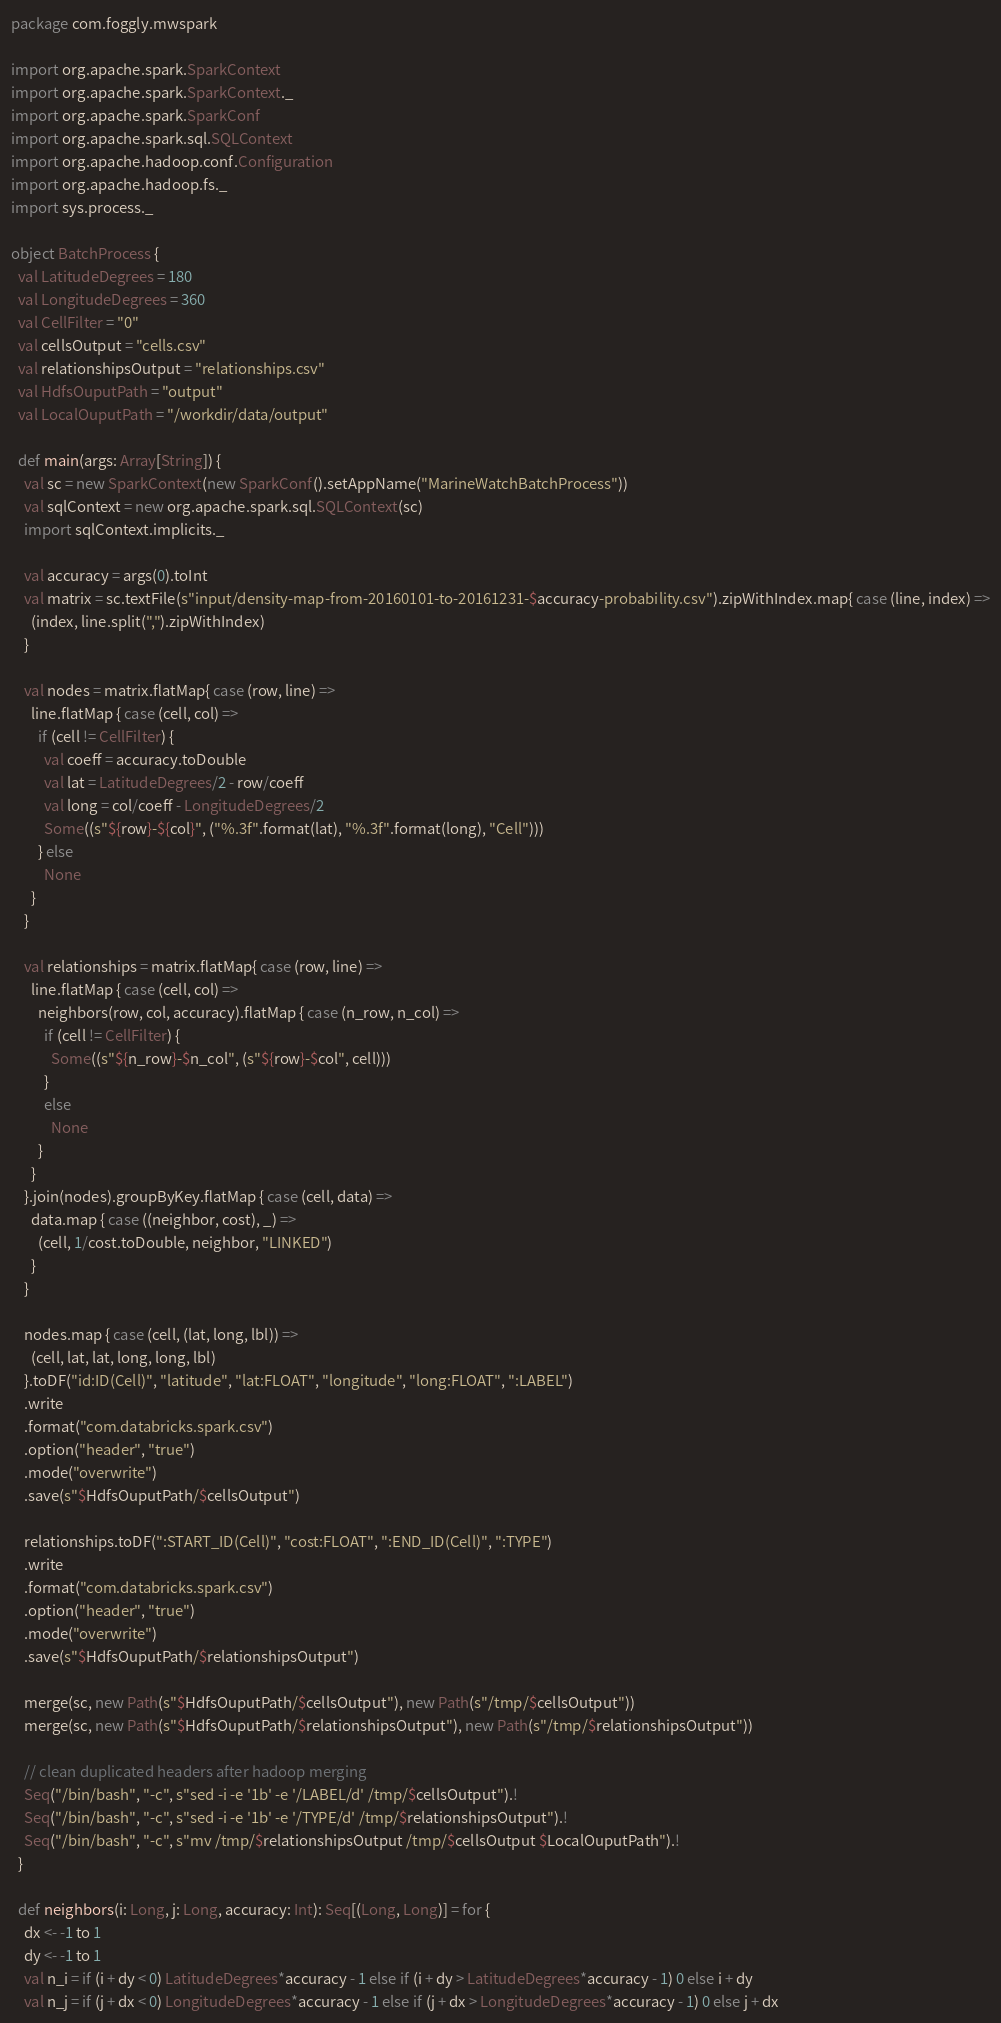Convert code to text. <code><loc_0><loc_0><loc_500><loc_500><_Scala_>package com.foggly.mwspark

import org.apache.spark.SparkContext
import org.apache.spark.SparkContext._
import org.apache.spark.SparkConf
import org.apache.spark.sql.SQLContext
import org.apache.hadoop.conf.Configuration
import org.apache.hadoop.fs._
import sys.process._

object BatchProcess {
  val LatitudeDegrees = 180
  val LongitudeDegrees = 360
  val CellFilter = "0"
  val cellsOutput = "cells.csv"
  val relationshipsOutput = "relationships.csv"
  val HdfsOuputPath = "output"
  val LocalOuputPath = "/workdir/data/output"

  def main(args: Array[String]) {
    val sc = new SparkContext(new SparkConf().setAppName("MarineWatchBatchProcess"))
    val sqlContext = new org.apache.spark.sql.SQLContext(sc)
    import sqlContext.implicits._

    val accuracy = args(0).toInt
    val matrix = sc.textFile(s"input/density-map-from-20160101-to-20161231-$accuracy-probability.csv").zipWithIndex.map{ case (line, index) =>
      (index, line.split(",").zipWithIndex)
    }

    val nodes = matrix.flatMap{ case (row, line) =>
      line.flatMap { case (cell, col) =>
        if (cell != CellFilter) {
          val coeff = accuracy.toDouble
          val lat = LatitudeDegrees/2 - row/coeff
          val long = col/coeff - LongitudeDegrees/2
          Some((s"${row}-${col}", ("%.3f".format(lat), "%.3f".format(long), "Cell")))
        } else
          None
      }
    }

    val relationships = matrix.flatMap{ case (row, line) =>
      line.flatMap { case (cell, col) =>
        neighbors(row, col, accuracy).flatMap { case (n_row, n_col) =>
          if (cell != CellFilter) {
            Some((s"${n_row}-$n_col", (s"${row}-$col", cell)))
          }
          else
            None
        }
      }
    }.join(nodes).groupByKey.flatMap { case (cell, data) =>
      data.map { case ((neighbor, cost), _) =>
        (cell, 1/cost.toDouble, neighbor, "LINKED")
      }
    }

    nodes.map { case (cell, (lat, long, lbl)) =>
      (cell, lat, lat, long, long, lbl)
    }.toDF("id:ID(Cell)", "latitude", "lat:FLOAT", "longitude", "long:FLOAT", ":LABEL")
    .write
    .format("com.databricks.spark.csv")
    .option("header", "true")
    .mode("overwrite")
    .save(s"$HdfsOuputPath/$cellsOutput")

    relationships.toDF(":START_ID(Cell)", "cost:FLOAT", ":END_ID(Cell)", ":TYPE")
    .write
    .format("com.databricks.spark.csv")
    .option("header", "true")
    .mode("overwrite")
    .save(s"$HdfsOuputPath/$relationshipsOutput")

    merge(sc, new Path(s"$HdfsOuputPath/$cellsOutput"), new Path(s"/tmp/$cellsOutput"))
    merge(sc, new Path(s"$HdfsOuputPath/$relationshipsOutput"), new Path(s"/tmp/$relationshipsOutput"))

    // clean duplicated headers after hadoop merging
    Seq("/bin/bash", "-c", s"sed -i -e '1b' -e '/LABEL/d' /tmp/$cellsOutput").!
    Seq("/bin/bash", "-c", s"sed -i -e '1b' -e '/TYPE/d' /tmp/$relationshipsOutput").!
    Seq("/bin/bash", "-c", s"mv /tmp/$relationshipsOutput /tmp/$cellsOutput $LocalOuputPath").!
  }

  def neighbors(i: Long, j: Long, accuracy: Int): Seq[(Long, Long)] = for {
    dx <- -1 to 1
    dy <- -1 to 1
    val n_i = if (i + dy < 0) LatitudeDegrees*accuracy - 1 else if (i + dy > LatitudeDegrees*accuracy - 1) 0 else i + dy
    val n_j = if (j + dx < 0) LongitudeDegrees*accuracy - 1 else if (j + dx > LongitudeDegrees*accuracy - 1) 0 else j + dx</code> 